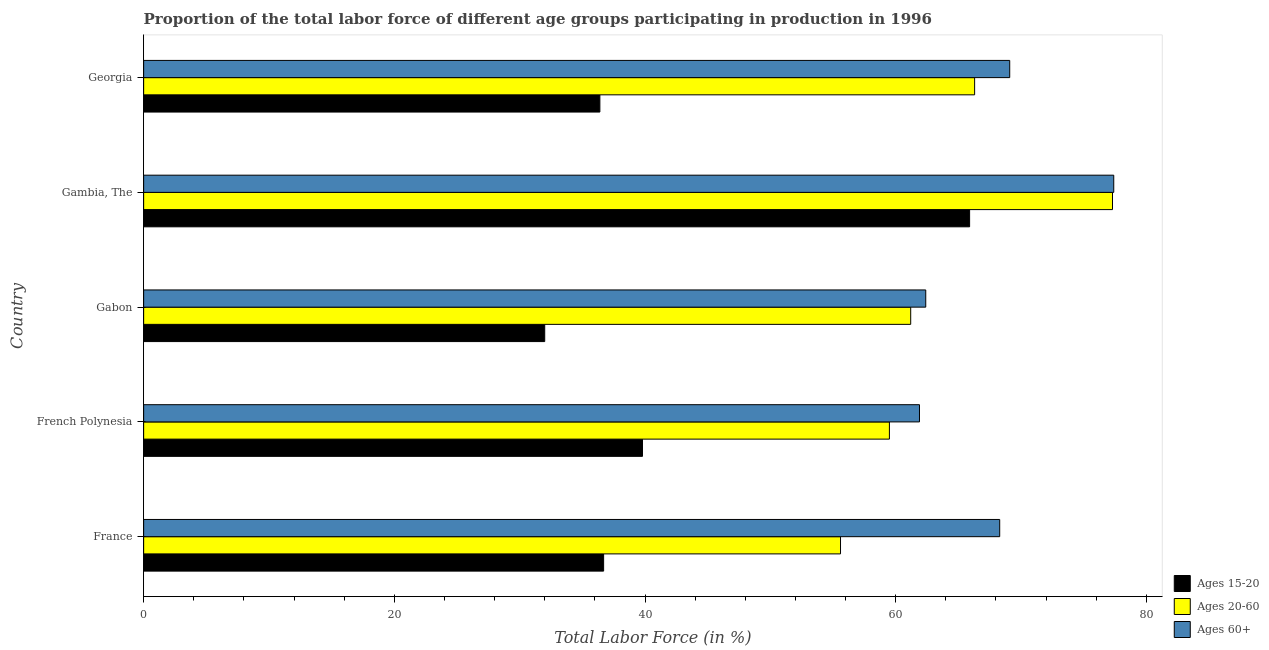How many different coloured bars are there?
Make the answer very short. 3. Are the number of bars per tick equal to the number of legend labels?
Offer a terse response. Yes. How many bars are there on the 3rd tick from the top?
Offer a very short reply. 3. How many bars are there on the 5th tick from the bottom?
Offer a very short reply. 3. What is the label of the 1st group of bars from the top?
Keep it short and to the point. Georgia. In how many cases, is the number of bars for a given country not equal to the number of legend labels?
Offer a very short reply. 0. What is the percentage of labor force within the age group 20-60 in Gabon?
Offer a very short reply. 61.2. Across all countries, what is the maximum percentage of labor force above age 60?
Keep it short and to the point. 77.4. In which country was the percentage of labor force within the age group 20-60 maximum?
Give a very brief answer. Gambia, The. In which country was the percentage of labor force above age 60 minimum?
Keep it short and to the point. French Polynesia. What is the total percentage of labor force above age 60 in the graph?
Your answer should be compact. 339.1. What is the difference between the percentage of labor force within the age group 15-20 in French Polynesia and that in Georgia?
Give a very brief answer. 3.4. What is the difference between the percentage of labor force within the age group 20-60 in Georgia and the percentage of labor force within the age group 15-20 in France?
Your answer should be compact. 29.6. What is the average percentage of labor force within the age group 20-60 per country?
Offer a very short reply. 63.98. In how many countries, is the percentage of labor force within the age group 15-20 greater than 72 %?
Keep it short and to the point. 0. What is the ratio of the percentage of labor force within the age group 20-60 in Gambia, The to that in Georgia?
Provide a short and direct response. 1.17. What is the difference between the highest and the second highest percentage of labor force within the age group 15-20?
Provide a short and direct response. 26.1. What is the difference between the highest and the lowest percentage of labor force above age 60?
Keep it short and to the point. 15.5. In how many countries, is the percentage of labor force within the age group 15-20 greater than the average percentage of labor force within the age group 15-20 taken over all countries?
Your answer should be compact. 1. What does the 1st bar from the top in Gabon represents?
Keep it short and to the point. Ages 60+. What does the 3rd bar from the bottom in Georgia represents?
Make the answer very short. Ages 60+. Is it the case that in every country, the sum of the percentage of labor force within the age group 15-20 and percentage of labor force within the age group 20-60 is greater than the percentage of labor force above age 60?
Make the answer very short. Yes. Are all the bars in the graph horizontal?
Offer a very short reply. Yes. What is the difference between two consecutive major ticks on the X-axis?
Provide a succinct answer. 20. Are the values on the major ticks of X-axis written in scientific E-notation?
Your answer should be compact. No. Where does the legend appear in the graph?
Make the answer very short. Bottom right. How are the legend labels stacked?
Provide a short and direct response. Vertical. What is the title of the graph?
Provide a short and direct response. Proportion of the total labor force of different age groups participating in production in 1996. Does "Secondary" appear as one of the legend labels in the graph?
Make the answer very short. No. What is the label or title of the X-axis?
Provide a short and direct response. Total Labor Force (in %). What is the label or title of the Y-axis?
Offer a very short reply. Country. What is the Total Labor Force (in %) of Ages 15-20 in France?
Provide a short and direct response. 36.7. What is the Total Labor Force (in %) in Ages 20-60 in France?
Provide a succinct answer. 55.6. What is the Total Labor Force (in %) in Ages 60+ in France?
Give a very brief answer. 68.3. What is the Total Labor Force (in %) of Ages 15-20 in French Polynesia?
Your response must be concise. 39.8. What is the Total Labor Force (in %) in Ages 20-60 in French Polynesia?
Provide a succinct answer. 59.5. What is the Total Labor Force (in %) in Ages 60+ in French Polynesia?
Offer a terse response. 61.9. What is the Total Labor Force (in %) of Ages 20-60 in Gabon?
Make the answer very short. 61.2. What is the Total Labor Force (in %) in Ages 60+ in Gabon?
Provide a succinct answer. 62.4. What is the Total Labor Force (in %) in Ages 15-20 in Gambia, The?
Your response must be concise. 65.9. What is the Total Labor Force (in %) in Ages 20-60 in Gambia, The?
Ensure brevity in your answer.  77.3. What is the Total Labor Force (in %) of Ages 60+ in Gambia, The?
Give a very brief answer. 77.4. What is the Total Labor Force (in %) of Ages 15-20 in Georgia?
Offer a very short reply. 36.4. What is the Total Labor Force (in %) in Ages 20-60 in Georgia?
Provide a succinct answer. 66.3. What is the Total Labor Force (in %) of Ages 60+ in Georgia?
Your response must be concise. 69.1. Across all countries, what is the maximum Total Labor Force (in %) in Ages 15-20?
Your response must be concise. 65.9. Across all countries, what is the maximum Total Labor Force (in %) in Ages 20-60?
Ensure brevity in your answer.  77.3. Across all countries, what is the maximum Total Labor Force (in %) of Ages 60+?
Your response must be concise. 77.4. Across all countries, what is the minimum Total Labor Force (in %) in Ages 20-60?
Your answer should be very brief. 55.6. Across all countries, what is the minimum Total Labor Force (in %) in Ages 60+?
Your answer should be very brief. 61.9. What is the total Total Labor Force (in %) of Ages 15-20 in the graph?
Offer a very short reply. 210.8. What is the total Total Labor Force (in %) of Ages 20-60 in the graph?
Ensure brevity in your answer.  319.9. What is the total Total Labor Force (in %) in Ages 60+ in the graph?
Your answer should be very brief. 339.1. What is the difference between the Total Labor Force (in %) in Ages 20-60 in France and that in French Polynesia?
Keep it short and to the point. -3.9. What is the difference between the Total Labor Force (in %) of Ages 60+ in France and that in Gabon?
Offer a terse response. 5.9. What is the difference between the Total Labor Force (in %) of Ages 15-20 in France and that in Gambia, The?
Your response must be concise. -29.2. What is the difference between the Total Labor Force (in %) in Ages 20-60 in France and that in Gambia, The?
Provide a short and direct response. -21.7. What is the difference between the Total Labor Force (in %) in Ages 15-20 in France and that in Georgia?
Make the answer very short. 0.3. What is the difference between the Total Labor Force (in %) in Ages 60+ in France and that in Georgia?
Provide a succinct answer. -0.8. What is the difference between the Total Labor Force (in %) in Ages 15-20 in French Polynesia and that in Gabon?
Offer a terse response. 7.8. What is the difference between the Total Labor Force (in %) in Ages 60+ in French Polynesia and that in Gabon?
Keep it short and to the point. -0.5. What is the difference between the Total Labor Force (in %) in Ages 15-20 in French Polynesia and that in Gambia, The?
Keep it short and to the point. -26.1. What is the difference between the Total Labor Force (in %) in Ages 20-60 in French Polynesia and that in Gambia, The?
Offer a very short reply. -17.8. What is the difference between the Total Labor Force (in %) in Ages 60+ in French Polynesia and that in Gambia, The?
Your answer should be compact. -15.5. What is the difference between the Total Labor Force (in %) of Ages 15-20 in Gabon and that in Gambia, The?
Offer a terse response. -33.9. What is the difference between the Total Labor Force (in %) in Ages 20-60 in Gabon and that in Gambia, The?
Ensure brevity in your answer.  -16.1. What is the difference between the Total Labor Force (in %) of Ages 60+ in Gabon and that in Georgia?
Give a very brief answer. -6.7. What is the difference between the Total Labor Force (in %) in Ages 15-20 in Gambia, The and that in Georgia?
Keep it short and to the point. 29.5. What is the difference between the Total Labor Force (in %) in Ages 20-60 in Gambia, The and that in Georgia?
Offer a very short reply. 11. What is the difference between the Total Labor Force (in %) in Ages 60+ in Gambia, The and that in Georgia?
Your answer should be compact. 8.3. What is the difference between the Total Labor Force (in %) of Ages 15-20 in France and the Total Labor Force (in %) of Ages 20-60 in French Polynesia?
Offer a very short reply. -22.8. What is the difference between the Total Labor Force (in %) of Ages 15-20 in France and the Total Labor Force (in %) of Ages 60+ in French Polynesia?
Keep it short and to the point. -25.2. What is the difference between the Total Labor Force (in %) of Ages 20-60 in France and the Total Labor Force (in %) of Ages 60+ in French Polynesia?
Your answer should be compact. -6.3. What is the difference between the Total Labor Force (in %) of Ages 15-20 in France and the Total Labor Force (in %) of Ages 20-60 in Gabon?
Make the answer very short. -24.5. What is the difference between the Total Labor Force (in %) of Ages 15-20 in France and the Total Labor Force (in %) of Ages 60+ in Gabon?
Your response must be concise. -25.7. What is the difference between the Total Labor Force (in %) of Ages 15-20 in France and the Total Labor Force (in %) of Ages 20-60 in Gambia, The?
Provide a short and direct response. -40.6. What is the difference between the Total Labor Force (in %) of Ages 15-20 in France and the Total Labor Force (in %) of Ages 60+ in Gambia, The?
Your answer should be very brief. -40.7. What is the difference between the Total Labor Force (in %) of Ages 20-60 in France and the Total Labor Force (in %) of Ages 60+ in Gambia, The?
Your answer should be very brief. -21.8. What is the difference between the Total Labor Force (in %) of Ages 15-20 in France and the Total Labor Force (in %) of Ages 20-60 in Georgia?
Offer a terse response. -29.6. What is the difference between the Total Labor Force (in %) of Ages 15-20 in France and the Total Labor Force (in %) of Ages 60+ in Georgia?
Give a very brief answer. -32.4. What is the difference between the Total Labor Force (in %) in Ages 15-20 in French Polynesia and the Total Labor Force (in %) in Ages 20-60 in Gabon?
Offer a terse response. -21.4. What is the difference between the Total Labor Force (in %) of Ages 15-20 in French Polynesia and the Total Labor Force (in %) of Ages 60+ in Gabon?
Ensure brevity in your answer.  -22.6. What is the difference between the Total Labor Force (in %) of Ages 15-20 in French Polynesia and the Total Labor Force (in %) of Ages 20-60 in Gambia, The?
Offer a terse response. -37.5. What is the difference between the Total Labor Force (in %) of Ages 15-20 in French Polynesia and the Total Labor Force (in %) of Ages 60+ in Gambia, The?
Keep it short and to the point. -37.6. What is the difference between the Total Labor Force (in %) in Ages 20-60 in French Polynesia and the Total Labor Force (in %) in Ages 60+ in Gambia, The?
Your answer should be compact. -17.9. What is the difference between the Total Labor Force (in %) in Ages 15-20 in French Polynesia and the Total Labor Force (in %) in Ages 20-60 in Georgia?
Give a very brief answer. -26.5. What is the difference between the Total Labor Force (in %) of Ages 15-20 in French Polynesia and the Total Labor Force (in %) of Ages 60+ in Georgia?
Give a very brief answer. -29.3. What is the difference between the Total Labor Force (in %) in Ages 20-60 in French Polynesia and the Total Labor Force (in %) in Ages 60+ in Georgia?
Offer a terse response. -9.6. What is the difference between the Total Labor Force (in %) of Ages 15-20 in Gabon and the Total Labor Force (in %) of Ages 20-60 in Gambia, The?
Offer a very short reply. -45.3. What is the difference between the Total Labor Force (in %) of Ages 15-20 in Gabon and the Total Labor Force (in %) of Ages 60+ in Gambia, The?
Make the answer very short. -45.4. What is the difference between the Total Labor Force (in %) in Ages 20-60 in Gabon and the Total Labor Force (in %) in Ages 60+ in Gambia, The?
Your response must be concise. -16.2. What is the difference between the Total Labor Force (in %) in Ages 15-20 in Gabon and the Total Labor Force (in %) in Ages 20-60 in Georgia?
Keep it short and to the point. -34.3. What is the difference between the Total Labor Force (in %) of Ages 15-20 in Gabon and the Total Labor Force (in %) of Ages 60+ in Georgia?
Provide a succinct answer. -37.1. What is the difference between the Total Labor Force (in %) in Ages 20-60 in Gabon and the Total Labor Force (in %) in Ages 60+ in Georgia?
Offer a terse response. -7.9. What is the average Total Labor Force (in %) of Ages 15-20 per country?
Provide a succinct answer. 42.16. What is the average Total Labor Force (in %) of Ages 20-60 per country?
Make the answer very short. 63.98. What is the average Total Labor Force (in %) in Ages 60+ per country?
Offer a very short reply. 67.82. What is the difference between the Total Labor Force (in %) in Ages 15-20 and Total Labor Force (in %) in Ages 20-60 in France?
Make the answer very short. -18.9. What is the difference between the Total Labor Force (in %) in Ages 15-20 and Total Labor Force (in %) in Ages 60+ in France?
Keep it short and to the point. -31.6. What is the difference between the Total Labor Force (in %) of Ages 15-20 and Total Labor Force (in %) of Ages 20-60 in French Polynesia?
Keep it short and to the point. -19.7. What is the difference between the Total Labor Force (in %) of Ages 15-20 and Total Labor Force (in %) of Ages 60+ in French Polynesia?
Ensure brevity in your answer.  -22.1. What is the difference between the Total Labor Force (in %) in Ages 15-20 and Total Labor Force (in %) in Ages 20-60 in Gabon?
Provide a short and direct response. -29.2. What is the difference between the Total Labor Force (in %) of Ages 15-20 and Total Labor Force (in %) of Ages 60+ in Gabon?
Give a very brief answer. -30.4. What is the difference between the Total Labor Force (in %) in Ages 20-60 and Total Labor Force (in %) in Ages 60+ in Gabon?
Provide a succinct answer. -1.2. What is the difference between the Total Labor Force (in %) of Ages 15-20 and Total Labor Force (in %) of Ages 60+ in Gambia, The?
Make the answer very short. -11.5. What is the difference between the Total Labor Force (in %) of Ages 20-60 and Total Labor Force (in %) of Ages 60+ in Gambia, The?
Provide a short and direct response. -0.1. What is the difference between the Total Labor Force (in %) in Ages 15-20 and Total Labor Force (in %) in Ages 20-60 in Georgia?
Ensure brevity in your answer.  -29.9. What is the difference between the Total Labor Force (in %) in Ages 15-20 and Total Labor Force (in %) in Ages 60+ in Georgia?
Your answer should be very brief. -32.7. What is the ratio of the Total Labor Force (in %) of Ages 15-20 in France to that in French Polynesia?
Make the answer very short. 0.92. What is the ratio of the Total Labor Force (in %) in Ages 20-60 in France to that in French Polynesia?
Your response must be concise. 0.93. What is the ratio of the Total Labor Force (in %) of Ages 60+ in France to that in French Polynesia?
Keep it short and to the point. 1.1. What is the ratio of the Total Labor Force (in %) in Ages 15-20 in France to that in Gabon?
Your response must be concise. 1.15. What is the ratio of the Total Labor Force (in %) in Ages 20-60 in France to that in Gabon?
Give a very brief answer. 0.91. What is the ratio of the Total Labor Force (in %) of Ages 60+ in France to that in Gabon?
Make the answer very short. 1.09. What is the ratio of the Total Labor Force (in %) of Ages 15-20 in France to that in Gambia, The?
Make the answer very short. 0.56. What is the ratio of the Total Labor Force (in %) in Ages 20-60 in France to that in Gambia, The?
Your answer should be very brief. 0.72. What is the ratio of the Total Labor Force (in %) of Ages 60+ in France to that in Gambia, The?
Give a very brief answer. 0.88. What is the ratio of the Total Labor Force (in %) of Ages 15-20 in France to that in Georgia?
Keep it short and to the point. 1.01. What is the ratio of the Total Labor Force (in %) in Ages 20-60 in France to that in Georgia?
Your answer should be very brief. 0.84. What is the ratio of the Total Labor Force (in %) in Ages 60+ in France to that in Georgia?
Ensure brevity in your answer.  0.99. What is the ratio of the Total Labor Force (in %) in Ages 15-20 in French Polynesia to that in Gabon?
Keep it short and to the point. 1.24. What is the ratio of the Total Labor Force (in %) in Ages 20-60 in French Polynesia to that in Gabon?
Offer a very short reply. 0.97. What is the ratio of the Total Labor Force (in %) in Ages 60+ in French Polynesia to that in Gabon?
Make the answer very short. 0.99. What is the ratio of the Total Labor Force (in %) in Ages 15-20 in French Polynesia to that in Gambia, The?
Make the answer very short. 0.6. What is the ratio of the Total Labor Force (in %) of Ages 20-60 in French Polynesia to that in Gambia, The?
Make the answer very short. 0.77. What is the ratio of the Total Labor Force (in %) in Ages 60+ in French Polynesia to that in Gambia, The?
Your answer should be very brief. 0.8. What is the ratio of the Total Labor Force (in %) of Ages 15-20 in French Polynesia to that in Georgia?
Keep it short and to the point. 1.09. What is the ratio of the Total Labor Force (in %) of Ages 20-60 in French Polynesia to that in Georgia?
Give a very brief answer. 0.9. What is the ratio of the Total Labor Force (in %) in Ages 60+ in French Polynesia to that in Georgia?
Your response must be concise. 0.9. What is the ratio of the Total Labor Force (in %) in Ages 15-20 in Gabon to that in Gambia, The?
Keep it short and to the point. 0.49. What is the ratio of the Total Labor Force (in %) of Ages 20-60 in Gabon to that in Gambia, The?
Ensure brevity in your answer.  0.79. What is the ratio of the Total Labor Force (in %) of Ages 60+ in Gabon to that in Gambia, The?
Give a very brief answer. 0.81. What is the ratio of the Total Labor Force (in %) in Ages 15-20 in Gabon to that in Georgia?
Your response must be concise. 0.88. What is the ratio of the Total Labor Force (in %) of Ages 20-60 in Gabon to that in Georgia?
Give a very brief answer. 0.92. What is the ratio of the Total Labor Force (in %) in Ages 60+ in Gabon to that in Georgia?
Your answer should be very brief. 0.9. What is the ratio of the Total Labor Force (in %) of Ages 15-20 in Gambia, The to that in Georgia?
Your answer should be compact. 1.81. What is the ratio of the Total Labor Force (in %) of Ages 20-60 in Gambia, The to that in Georgia?
Provide a succinct answer. 1.17. What is the ratio of the Total Labor Force (in %) in Ages 60+ in Gambia, The to that in Georgia?
Offer a very short reply. 1.12. What is the difference between the highest and the second highest Total Labor Force (in %) in Ages 15-20?
Your answer should be very brief. 26.1. What is the difference between the highest and the second highest Total Labor Force (in %) in Ages 20-60?
Your answer should be very brief. 11. What is the difference between the highest and the lowest Total Labor Force (in %) in Ages 15-20?
Your answer should be compact. 33.9. What is the difference between the highest and the lowest Total Labor Force (in %) in Ages 20-60?
Your response must be concise. 21.7. 